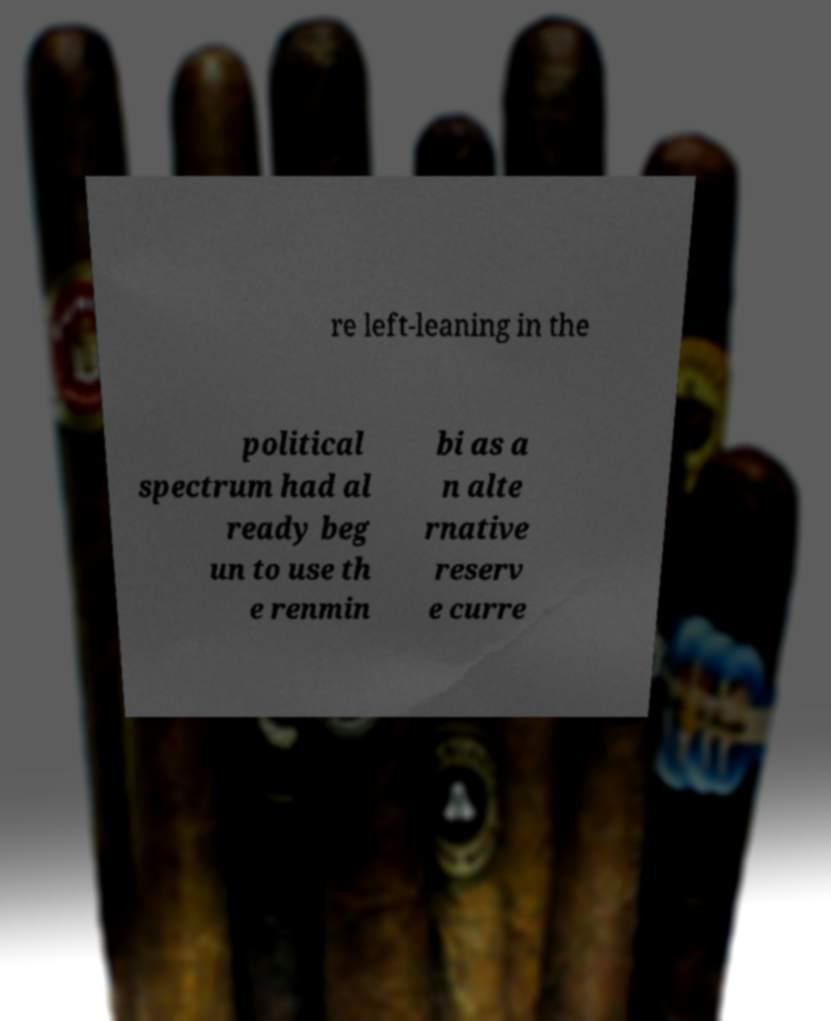Could you assist in decoding the text presented in this image and type it out clearly? re left-leaning in the political spectrum had al ready beg un to use th e renmin bi as a n alte rnative reserv e curre 